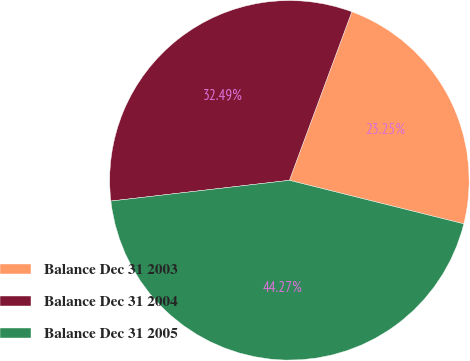Convert chart. <chart><loc_0><loc_0><loc_500><loc_500><pie_chart><fcel>Balance Dec 31 2003<fcel>Balance Dec 31 2004<fcel>Balance Dec 31 2005<nl><fcel>23.25%<fcel>32.49%<fcel>44.27%<nl></chart> 